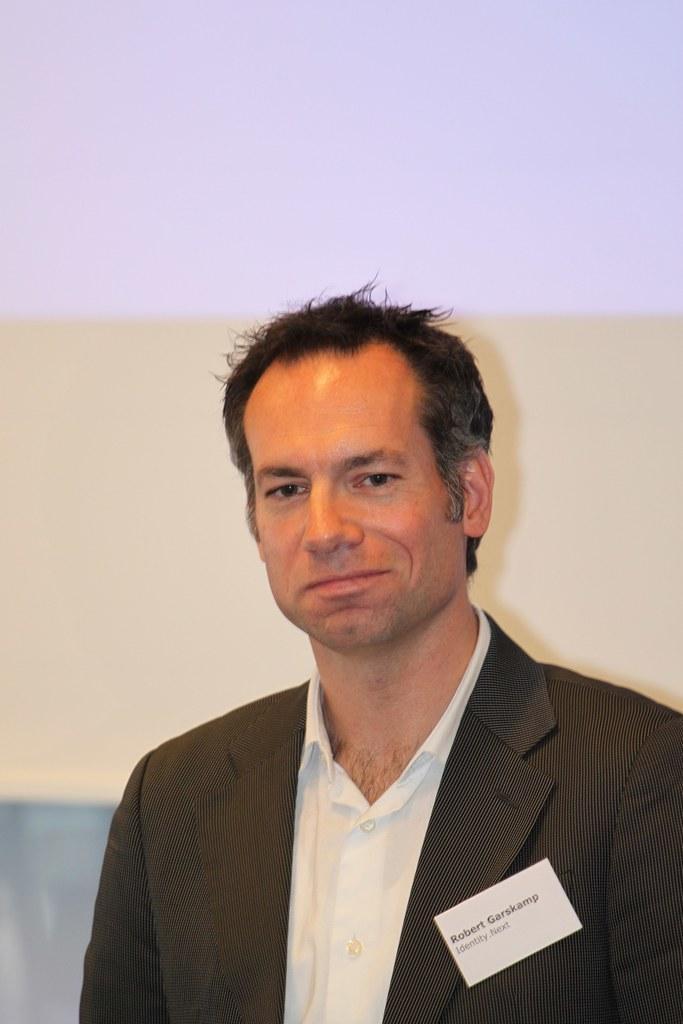Could you give a brief overview of what you see in this image? In the center of the image we can see a man is smiling and wearing a suit and also we can see a paper. On the paper, we can see the text. In the background of the image we can see the wall. 